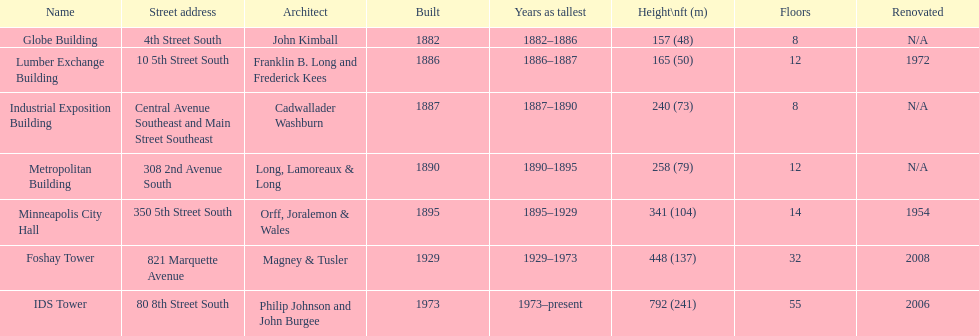Is the metropolitan building or the lumber exchange building taller? Metropolitan Building. 